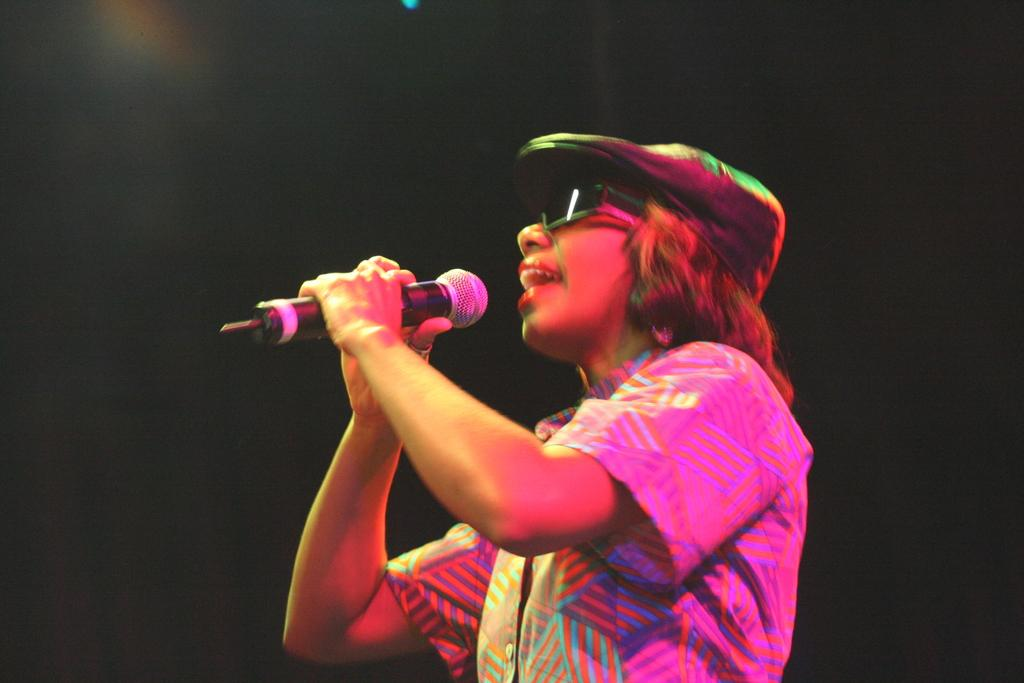What is the main subject of the image? There is a person in the image. What is the person doing in the image? The person is singing. What object is the person holding in the image? The person is holding a microphone. What can be observed about the background of the image? The background of the image is dark. What type of engine can be seen powering the person's performance in the image? There is no engine present in the image; the person is singing while holding a microphone. 